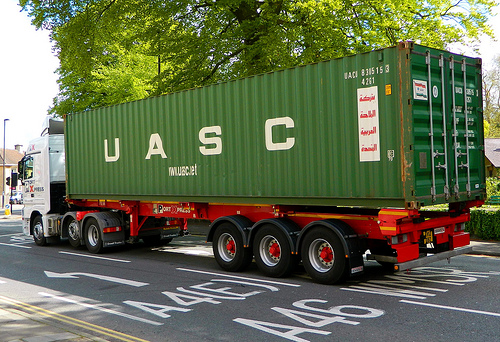Is the taxi on the right? No, the taxi is not on the right. 